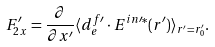Convert formula to latex. <formula><loc_0><loc_0><loc_500><loc_500>F _ { 2 x } ^ { \prime } = \frac { \partial } { \partial x ^ { \prime } } \langle d _ { e } ^ { f \prime } \cdot E ^ { i n \prime * } ( r ^ { \prime } ) \rangle _ { r ^ { \prime } = r ^ { \prime } _ { 0 } } .</formula> 